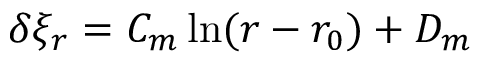Convert formula to latex. <formula><loc_0><loc_0><loc_500><loc_500>\delta \xi _ { r } = C _ { m } \ln ( r - r _ { 0 } ) + D _ { m }</formula> 